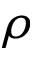<formula> <loc_0><loc_0><loc_500><loc_500>\rho</formula> 